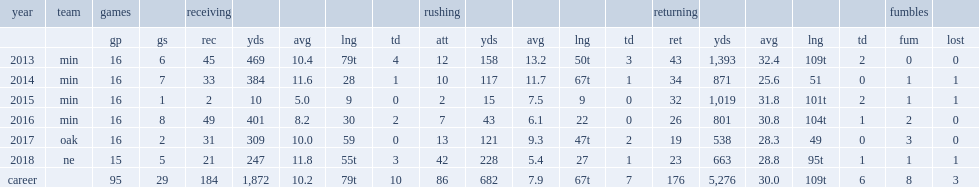How many receptions did patterson finish the 2017 season with? 31.0. 